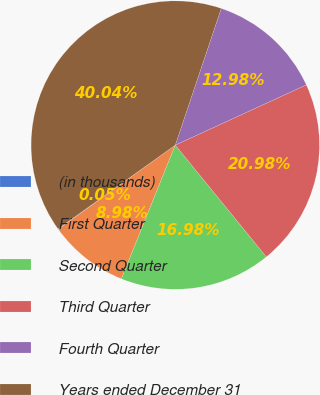Convert chart to OTSL. <chart><loc_0><loc_0><loc_500><loc_500><pie_chart><fcel>(in thousands)<fcel>First Quarter<fcel>Second Quarter<fcel>Third Quarter<fcel>Fourth Quarter<fcel>Years ended December 31<nl><fcel>0.05%<fcel>8.98%<fcel>16.98%<fcel>20.98%<fcel>12.98%<fcel>40.04%<nl></chart> 